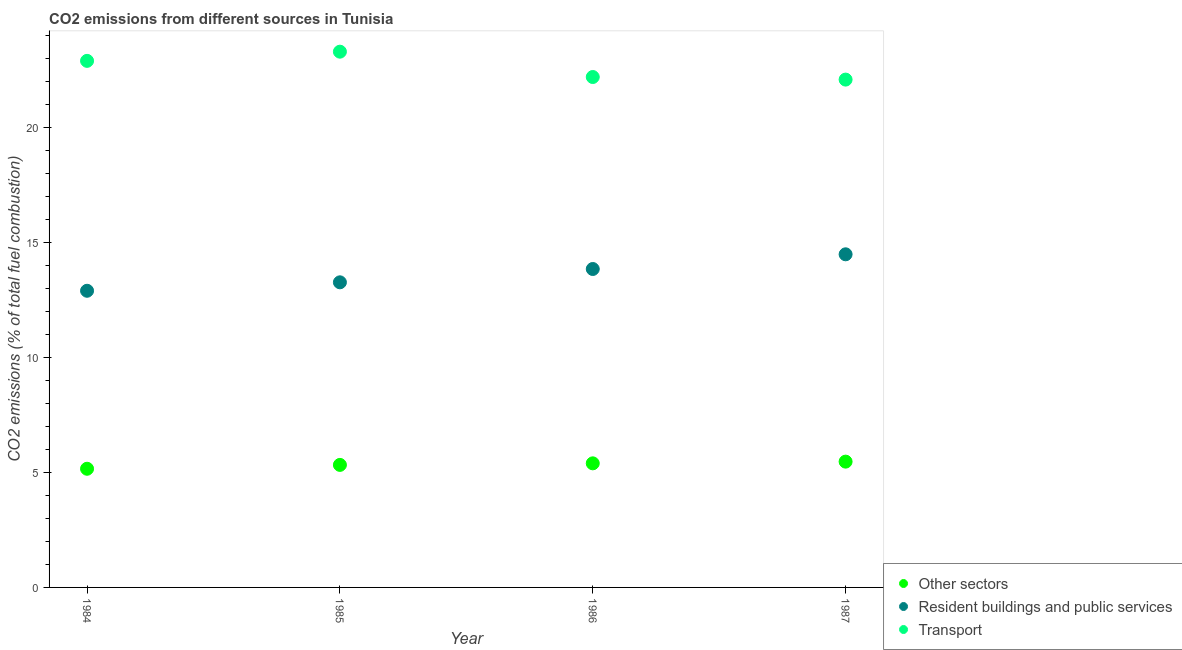Is the number of dotlines equal to the number of legend labels?
Your answer should be compact. Yes. What is the percentage of co2 emissions from other sectors in 1987?
Make the answer very short. 5.47. Across all years, what is the maximum percentage of co2 emissions from other sectors?
Provide a succinct answer. 5.47. Across all years, what is the minimum percentage of co2 emissions from resident buildings and public services?
Ensure brevity in your answer.  12.89. In which year was the percentage of co2 emissions from transport maximum?
Make the answer very short. 1985. What is the total percentage of co2 emissions from resident buildings and public services in the graph?
Your answer should be compact. 54.46. What is the difference between the percentage of co2 emissions from resident buildings and public services in 1985 and that in 1986?
Ensure brevity in your answer.  -0.58. What is the difference between the percentage of co2 emissions from transport in 1987 and the percentage of co2 emissions from resident buildings and public services in 1986?
Provide a short and direct response. 8.23. What is the average percentage of co2 emissions from transport per year?
Your response must be concise. 22.6. In the year 1985, what is the difference between the percentage of co2 emissions from resident buildings and public services and percentage of co2 emissions from other sectors?
Give a very brief answer. 7.93. In how many years, is the percentage of co2 emissions from transport greater than 22 %?
Ensure brevity in your answer.  4. What is the ratio of the percentage of co2 emissions from other sectors in 1985 to that in 1987?
Give a very brief answer. 0.97. Is the percentage of co2 emissions from other sectors in 1985 less than that in 1986?
Make the answer very short. Yes. What is the difference between the highest and the second highest percentage of co2 emissions from other sectors?
Your answer should be compact. 0.07. What is the difference between the highest and the lowest percentage of co2 emissions from other sectors?
Offer a terse response. 0.31. In how many years, is the percentage of co2 emissions from other sectors greater than the average percentage of co2 emissions from other sectors taken over all years?
Offer a terse response. 2. Is it the case that in every year, the sum of the percentage of co2 emissions from other sectors and percentage of co2 emissions from resident buildings and public services is greater than the percentage of co2 emissions from transport?
Your response must be concise. No. Does the percentage of co2 emissions from transport monotonically increase over the years?
Your response must be concise. No. How many dotlines are there?
Ensure brevity in your answer.  3. What is the difference between two consecutive major ticks on the Y-axis?
Make the answer very short. 5. How many legend labels are there?
Ensure brevity in your answer.  3. What is the title of the graph?
Ensure brevity in your answer.  CO2 emissions from different sources in Tunisia. What is the label or title of the Y-axis?
Keep it short and to the point. CO2 emissions (% of total fuel combustion). What is the CO2 emissions (% of total fuel combustion) in Other sectors in 1984?
Ensure brevity in your answer.  5.16. What is the CO2 emissions (% of total fuel combustion) of Resident buildings and public services in 1984?
Offer a terse response. 12.89. What is the CO2 emissions (% of total fuel combustion) in Transport in 1984?
Your response must be concise. 22.88. What is the CO2 emissions (% of total fuel combustion) of Other sectors in 1985?
Give a very brief answer. 5.32. What is the CO2 emissions (% of total fuel combustion) of Resident buildings and public services in 1985?
Offer a terse response. 13.26. What is the CO2 emissions (% of total fuel combustion) of Transport in 1985?
Ensure brevity in your answer.  23.28. What is the CO2 emissions (% of total fuel combustion) of Other sectors in 1986?
Ensure brevity in your answer.  5.39. What is the CO2 emissions (% of total fuel combustion) of Resident buildings and public services in 1986?
Provide a succinct answer. 13.84. What is the CO2 emissions (% of total fuel combustion) in Transport in 1986?
Provide a succinct answer. 22.18. What is the CO2 emissions (% of total fuel combustion) of Other sectors in 1987?
Keep it short and to the point. 5.47. What is the CO2 emissions (% of total fuel combustion) in Resident buildings and public services in 1987?
Ensure brevity in your answer.  14.47. What is the CO2 emissions (% of total fuel combustion) of Transport in 1987?
Offer a terse response. 22.06. Across all years, what is the maximum CO2 emissions (% of total fuel combustion) in Other sectors?
Your answer should be compact. 5.47. Across all years, what is the maximum CO2 emissions (% of total fuel combustion) in Resident buildings and public services?
Offer a very short reply. 14.47. Across all years, what is the maximum CO2 emissions (% of total fuel combustion) in Transport?
Provide a succinct answer. 23.28. Across all years, what is the minimum CO2 emissions (% of total fuel combustion) in Other sectors?
Give a very brief answer. 5.16. Across all years, what is the minimum CO2 emissions (% of total fuel combustion) of Resident buildings and public services?
Give a very brief answer. 12.89. Across all years, what is the minimum CO2 emissions (% of total fuel combustion) of Transport?
Your answer should be compact. 22.06. What is the total CO2 emissions (% of total fuel combustion) in Other sectors in the graph?
Provide a short and direct response. 21.34. What is the total CO2 emissions (% of total fuel combustion) in Resident buildings and public services in the graph?
Offer a terse response. 54.45. What is the total CO2 emissions (% of total fuel combustion) in Transport in the graph?
Provide a short and direct response. 90.4. What is the difference between the CO2 emissions (% of total fuel combustion) in Other sectors in 1984 and that in 1985?
Give a very brief answer. -0.17. What is the difference between the CO2 emissions (% of total fuel combustion) of Resident buildings and public services in 1984 and that in 1985?
Give a very brief answer. -0.37. What is the difference between the CO2 emissions (% of total fuel combustion) of Transport in 1984 and that in 1985?
Give a very brief answer. -0.4. What is the difference between the CO2 emissions (% of total fuel combustion) of Other sectors in 1984 and that in 1986?
Make the answer very short. -0.24. What is the difference between the CO2 emissions (% of total fuel combustion) of Resident buildings and public services in 1984 and that in 1986?
Ensure brevity in your answer.  -0.95. What is the difference between the CO2 emissions (% of total fuel combustion) in Transport in 1984 and that in 1986?
Provide a short and direct response. 0.7. What is the difference between the CO2 emissions (% of total fuel combustion) of Other sectors in 1984 and that in 1987?
Offer a very short reply. -0.31. What is the difference between the CO2 emissions (% of total fuel combustion) of Resident buildings and public services in 1984 and that in 1987?
Offer a very short reply. -1.58. What is the difference between the CO2 emissions (% of total fuel combustion) of Transport in 1984 and that in 1987?
Keep it short and to the point. 0.81. What is the difference between the CO2 emissions (% of total fuel combustion) in Other sectors in 1985 and that in 1986?
Offer a very short reply. -0.07. What is the difference between the CO2 emissions (% of total fuel combustion) of Resident buildings and public services in 1985 and that in 1986?
Give a very brief answer. -0.58. What is the difference between the CO2 emissions (% of total fuel combustion) of Transport in 1985 and that in 1986?
Keep it short and to the point. 1.1. What is the difference between the CO2 emissions (% of total fuel combustion) of Other sectors in 1985 and that in 1987?
Give a very brief answer. -0.14. What is the difference between the CO2 emissions (% of total fuel combustion) of Resident buildings and public services in 1985 and that in 1987?
Keep it short and to the point. -1.22. What is the difference between the CO2 emissions (% of total fuel combustion) in Transport in 1985 and that in 1987?
Your response must be concise. 1.21. What is the difference between the CO2 emissions (% of total fuel combustion) in Other sectors in 1986 and that in 1987?
Offer a very short reply. -0.07. What is the difference between the CO2 emissions (% of total fuel combustion) of Resident buildings and public services in 1986 and that in 1987?
Your answer should be very brief. -0.64. What is the difference between the CO2 emissions (% of total fuel combustion) of Transport in 1986 and that in 1987?
Keep it short and to the point. 0.11. What is the difference between the CO2 emissions (% of total fuel combustion) of Other sectors in 1984 and the CO2 emissions (% of total fuel combustion) of Resident buildings and public services in 1985?
Keep it short and to the point. -8.1. What is the difference between the CO2 emissions (% of total fuel combustion) of Other sectors in 1984 and the CO2 emissions (% of total fuel combustion) of Transport in 1985?
Provide a short and direct response. -18.12. What is the difference between the CO2 emissions (% of total fuel combustion) in Resident buildings and public services in 1984 and the CO2 emissions (% of total fuel combustion) in Transport in 1985?
Your answer should be compact. -10.39. What is the difference between the CO2 emissions (% of total fuel combustion) in Other sectors in 1984 and the CO2 emissions (% of total fuel combustion) in Resident buildings and public services in 1986?
Ensure brevity in your answer.  -8.68. What is the difference between the CO2 emissions (% of total fuel combustion) of Other sectors in 1984 and the CO2 emissions (% of total fuel combustion) of Transport in 1986?
Your answer should be very brief. -17.02. What is the difference between the CO2 emissions (% of total fuel combustion) in Resident buildings and public services in 1984 and the CO2 emissions (% of total fuel combustion) in Transport in 1986?
Your response must be concise. -9.29. What is the difference between the CO2 emissions (% of total fuel combustion) of Other sectors in 1984 and the CO2 emissions (% of total fuel combustion) of Resident buildings and public services in 1987?
Make the answer very short. -9.32. What is the difference between the CO2 emissions (% of total fuel combustion) in Other sectors in 1984 and the CO2 emissions (% of total fuel combustion) in Transport in 1987?
Keep it short and to the point. -16.91. What is the difference between the CO2 emissions (% of total fuel combustion) in Resident buildings and public services in 1984 and the CO2 emissions (% of total fuel combustion) in Transport in 1987?
Ensure brevity in your answer.  -9.18. What is the difference between the CO2 emissions (% of total fuel combustion) in Other sectors in 1985 and the CO2 emissions (% of total fuel combustion) in Resident buildings and public services in 1986?
Ensure brevity in your answer.  -8.51. What is the difference between the CO2 emissions (% of total fuel combustion) of Other sectors in 1985 and the CO2 emissions (% of total fuel combustion) of Transport in 1986?
Offer a terse response. -16.85. What is the difference between the CO2 emissions (% of total fuel combustion) of Resident buildings and public services in 1985 and the CO2 emissions (% of total fuel combustion) of Transport in 1986?
Provide a succinct answer. -8.92. What is the difference between the CO2 emissions (% of total fuel combustion) in Other sectors in 1985 and the CO2 emissions (% of total fuel combustion) in Resident buildings and public services in 1987?
Your response must be concise. -9.15. What is the difference between the CO2 emissions (% of total fuel combustion) in Other sectors in 1985 and the CO2 emissions (% of total fuel combustion) in Transport in 1987?
Give a very brief answer. -16.74. What is the difference between the CO2 emissions (% of total fuel combustion) of Resident buildings and public services in 1985 and the CO2 emissions (% of total fuel combustion) of Transport in 1987?
Ensure brevity in your answer.  -8.81. What is the difference between the CO2 emissions (% of total fuel combustion) in Other sectors in 1986 and the CO2 emissions (% of total fuel combustion) in Resident buildings and public services in 1987?
Give a very brief answer. -9.08. What is the difference between the CO2 emissions (% of total fuel combustion) in Other sectors in 1986 and the CO2 emissions (% of total fuel combustion) in Transport in 1987?
Your answer should be compact. -16.67. What is the difference between the CO2 emissions (% of total fuel combustion) of Resident buildings and public services in 1986 and the CO2 emissions (% of total fuel combustion) of Transport in 1987?
Give a very brief answer. -8.23. What is the average CO2 emissions (% of total fuel combustion) of Other sectors per year?
Provide a short and direct response. 5.33. What is the average CO2 emissions (% of total fuel combustion) in Resident buildings and public services per year?
Provide a short and direct response. 13.61. What is the average CO2 emissions (% of total fuel combustion) in Transport per year?
Provide a short and direct response. 22.6. In the year 1984, what is the difference between the CO2 emissions (% of total fuel combustion) of Other sectors and CO2 emissions (% of total fuel combustion) of Resident buildings and public services?
Your response must be concise. -7.73. In the year 1984, what is the difference between the CO2 emissions (% of total fuel combustion) of Other sectors and CO2 emissions (% of total fuel combustion) of Transport?
Your answer should be compact. -17.72. In the year 1984, what is the difference between the CO2 emissions (% of total fuel combustion) of Resident buildings and public services and CO2 emissions (% of total fuel combustion) of Transport?
Your answer should be very brief. -9.99. In the year 1985, what is the difference between the CO2 emissions (% of total fuel combustion) of Other sectors and CO2 emissions (% of total fuel combustion) of Resident buildings and public services?
Offer a terse response. -7.93. In the year 1985, what is the difference between the CO2 emissions (% of total fuel combustion) in Other sectors and CO2 emissions (% of total fuel combustion) in Transport?
Offer a very short reply. -17.95. In the year 1985, what is the difference between the CO2 emissions (% of total fuel combustion) of Resident buildings and public services and CO2 emissions (% of total fuel combustion) of Transport?
Keep it short and to the point. -10.02. In the year 1986, what is the difference between the CO2 emissions (% of total fuel combustion) of Other sectors and CO2 emissions (% of total fuel combustion) of Resident buildings and public services?
Your answer should be compact. -8.44. In the year 1986, what is the difference between the CO2 emissions (% of total fuel combustion) in Other sectors and CO2 emissions (% of total fuel combustion) in Transport?
Offer a very short reply. -16.79. In the year 1986, what is the difference between the CO2 emissions (% of total fuel combustion) of Resident buildings and public services and CO2 emissions (% of total fuel combustion) of Transport?
Your response must be concise. -8.34. In the year 1987, what is the difference between the CO2 emissions (% of total fuel combustion) of Other sectors and CO2 emissions (% of total fuel combustion) of Resident buildings and public services?
Keep it short and to the point. -9.01. In the year 1987, what is the difference between the CO2 emissions (% of total fuel combustion) in Other sectors and CO2 emissions (% of total fuel combustion) in Transport?
Provide a short and direct response. -16.6. In the year 1987, what is the difference between the CO2 emissions (% of total fuel combustion) of Resident buildings and public services and CO2 emissions (% of total fuel combustion) of Transport?
Provide a short and direct response. -7.59. What is the ratio of the CO2 emissions (% of total fuel combustion) of Other sectors in 1984 to that in 1985?
Your answer should be very brief. 0.97. What is the ratio of the CO2 emissions (% of total fuel combustion) in Resident buildings and public services in 1984 to that in 1985?
Your answer should be compact. 0.97. What is the ratio of the CO2 emissions (% of total fuel combustion) in Transport in 1984 to that in 1985?
Offer a terse response. 0.98. What is the ratio of the CO2 emissions (% of total fuel combustion) of Other sectors in 1984 to that in 1986?
Provide a short and direct response. 0.96. What is the ratio of the CO2 emissions (% of total fuel combustion) in Resident buildings and public services in 1984 to that in 1986?
Make the answer very short. 0.93. What is the ratio of the CO2 emissions (% of total fuel combustion) of Transport in 1984 to that in 1986?
Keep it short and to the point. 1.03. What is the ratio of the CO2 emissions (% of total fuel combustion) in Other sectors in 1984 to that in 1987?
Provide a succinct answer. 0.94. What is the ratio of the CO2 emissions (% of total fuel combustion) of Resident buildings and public services in 1984 to that in 1987?
Provide a succinct answer. 0.89. What is the ratio of the CO2 emissions (% of total fuel combustion) in Transport in 1984 to that in 1987?
Offer a terse response. 1.04. What is the ratio of the CO2 emissions (% of total fuel combustion) of Other sectors in 1985 to that in 1986?
Your response must be concise. 0.99. What is the ratio of the CO2 emissions (% of total fuel combustion) in Resident buildings and public services in 1985 to that in 1986?
Provide a succinct answer. 0.96. What is the ratio of the CO2 emissions (% of total fuel combustion) in Transport in 1985 to that in 1986?
Provide a succinct answer. 1.05. What is the ratio of the CO2 emissions (% of total fuel combustion) of Resident buildings and public services in 1985 to that in 1987?
Keep it short and to the point. 0.92. What is the ratio of the CO2 emissions (% of total fuel combustion) of Transport in 1985 to that in 1987?
Your response must be concise. 1.05. What is the ratio of the CO2 emissions (% of total fuel combustion) of Other sectors in 1986 to that in 1987?
Make the answer very short. 0.99. What is the ratio of the CO2 emissions (% of total fuel combustion) of Resident buildings and public services in 1986 to that in 1987?
Make the answer very short. 0.96. What is the difference between the highest and the second highest CO2 emissions (% of total fuel combustion) in Other sectors?
Provide a short and direct response. 0.07. What is the difference between the highest and the second highest CO2 emissions (% of total fuel combustion) in Resident buildings and public services?
Your response must be concise. 0.64. What is the difference between the highest and the second highest CO2 emissions (% of total fuel combustion) of Transport?
Provide a succinct answer. 0.4. What is the difference between the highest and the lowest CO2 emissions (% of total fuel combustion) of Other sectors?
Keep it short and to the point. 0.31. What is the difference between the highest and the lowest CO2 emissions (% of total fuel combustion) in Resident buildings and public services?
Offer a terse response. 1.58. What is the difference between the highest and the lowest CO2 emissions (% of total fuel combustion) in Transport?
Provide a succinct answer. 1.21. 